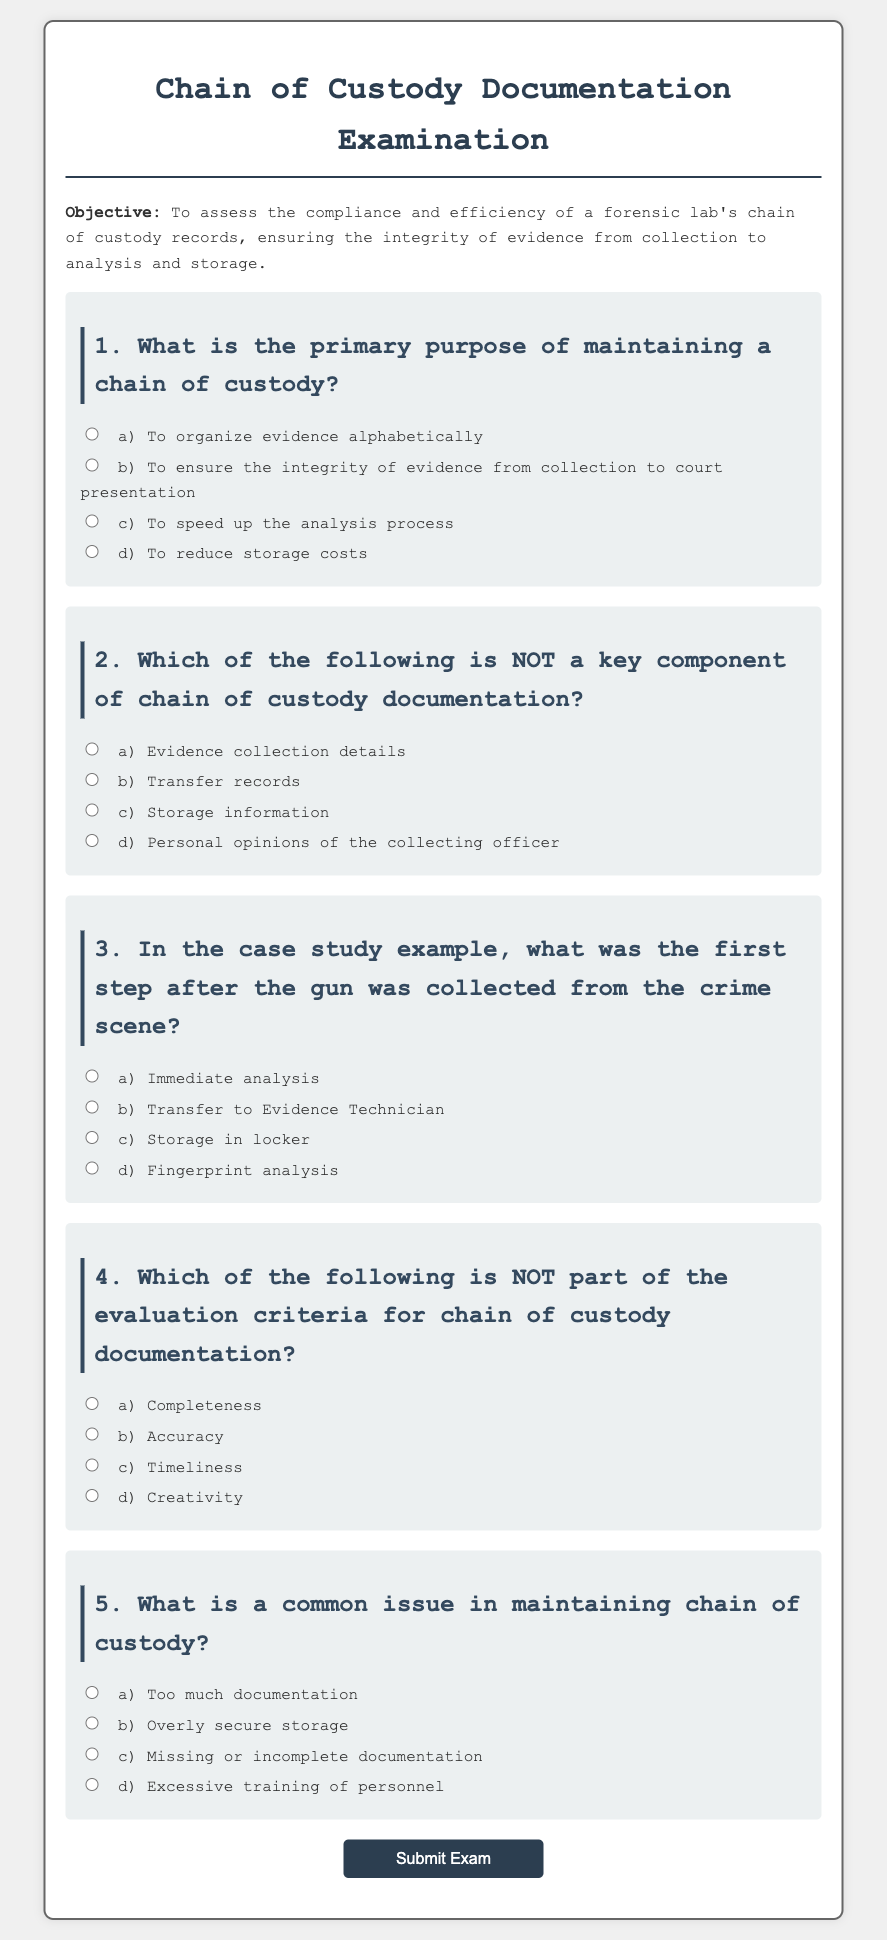What is the primary purpose of maintaining a chain of custody? The primary purpose is to ensure the integrity of evidence from collection to court presentation, aiding in legal proceedings.
Answer: To ensure the integrity of evidence from collection to court presentation Which key component is NOT included in chain of custody documentation? The documentation must include evidence collection details, transfer records, and storage information, but personal opinions are not appropriate.
Answer: Personal opinions of the collecting officer What is the first step after the gun was collected from the crime scene? According to the document, the first step was the transfer to Evidence Technician following the collection of the gun.
Answer: Transfer to Evidence Technician Which evaluation criterion is NOT relevant for chain of custody documentation? The criteria for evaluation focus on completeness, accuracy, and timeliness, while creativity is unrelated and unnecessary.
Answer: Creativity What is a common issue with maintaining chain of custody? The document highlights that a frequent problem is missing or incomplete documentation, which can jeopardize evidence integrity.
Answer: Missing or incomplete documentation 